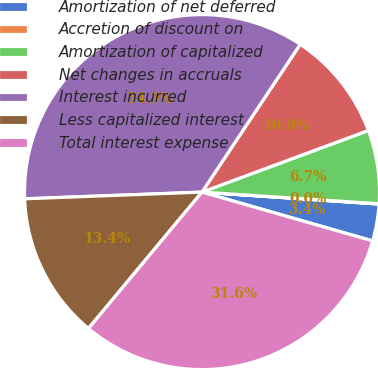Convert chart to OTSL. <chart><loc_0><loc_0><loc_500><loc_500><pie_chart><fcel>Amortization of net deferred<fcel>Accretion of discount on<fcel>Amortization of capitalized<fcel>Net changes in accruals<fcel>Interest incurred<fcel>Less capitalized interest<fcel>Total interest expense<nl><fcel>3.36%<fcel>0.03%<fcel>6.69%<fcel>10.02%<fcel>34.94%<fcel>13.35%<fcel>31.61%<nl></chart> 